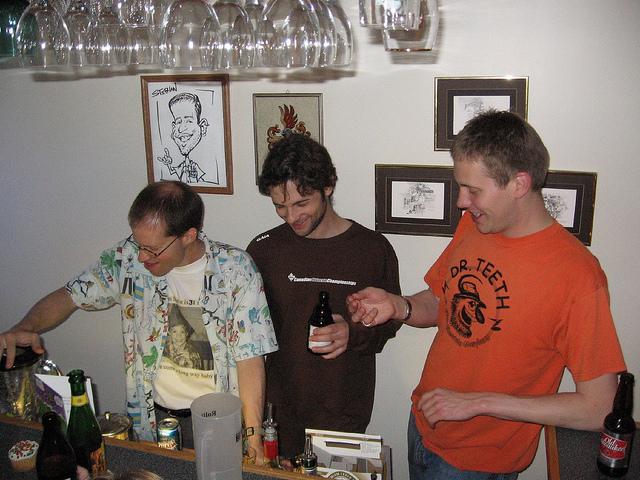What pictures are there on the walls?
Write a very short answer. Cartoons. Is the framed picture on the left a real photograph or a caricature?
Answer briefly. Caricature. Are the glasses hanging upside down?
Be succinct. Yes. 